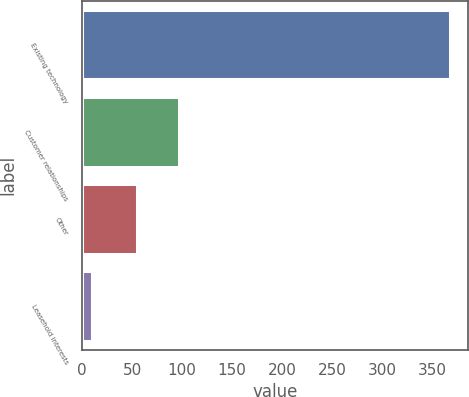<chart> <loc_0><loc_0><loc_500><loc_500><bar_chart><fcel>Existing technology<fcel>Customer relationships<fcel>Other<fcel>Leasehold interests<nl><fcel>368<fcel>97<fcel>55<fcel>10<nl></chart> 